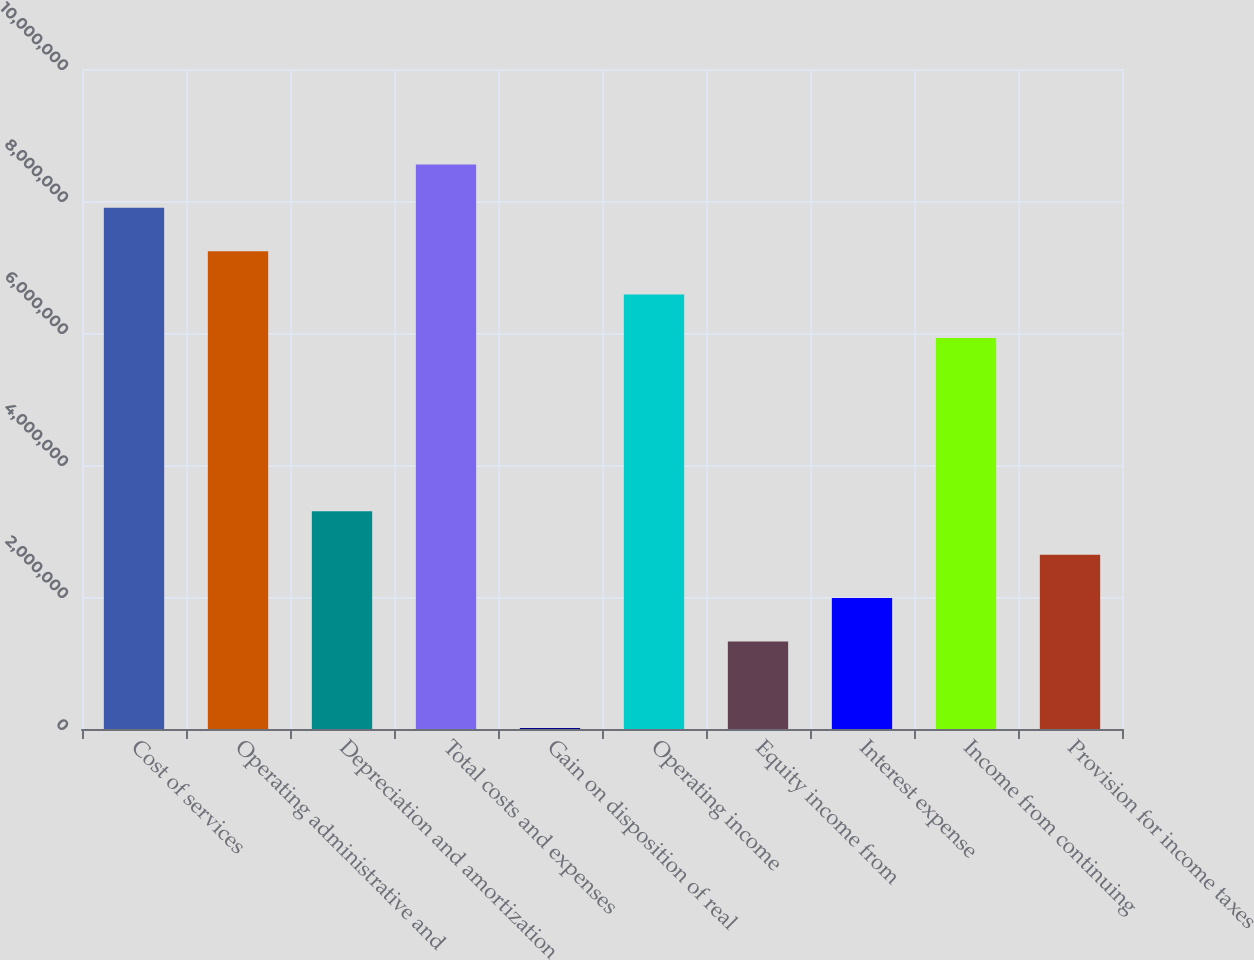<chart> <loc_0><loc_0><loc_500><loc_500><bar_chart><fcel>Cost of services<fcel>Operating administrative and<fcel>Depreciation and amortization<fcel>Total costs and expenses<fcel>Gain on disposition of real<fcel>Operating income<fcel>Equity income from<fcel>Interest expense<fcel>Income from continuing<fcel>Provision for income taxes<nl><fcel>7.89595e+06<fcel>7.23908e+06<fcel>3.29788e+06<fcel>8.55282e+06<fcel>13552<fcel>6.58222e+06<fcel>1.32729e+06<fcel>1.98415e+06<fcel>5.92535e+06<fcel>2.64102e+06<nl></chart> 